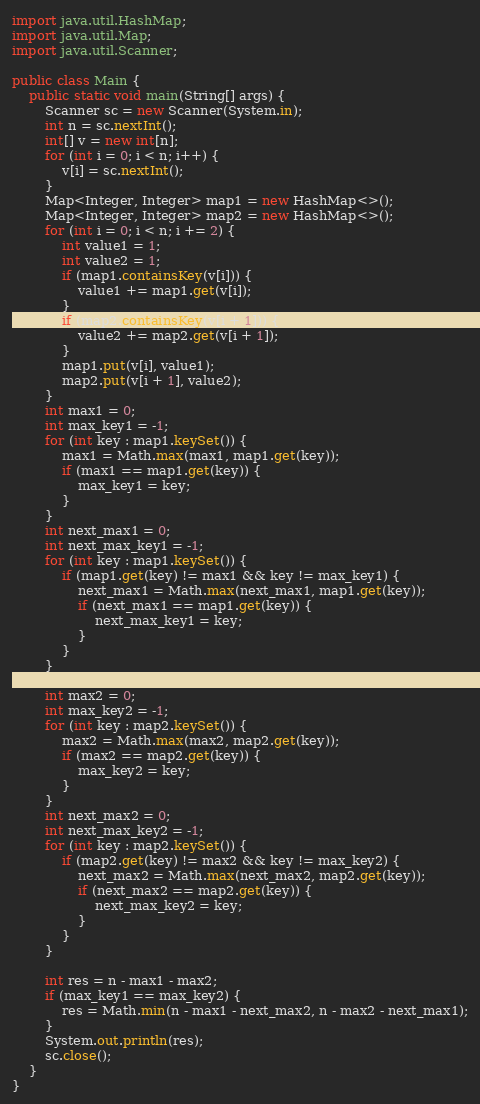<code> <loc_0><loc_0><loc_500><loc_500><_Java_>import java.util.HashMap;
import java.util.Map;
import java.util.Scanner;

public class Main {
    public static void main(String[] args) {
        Scanner sc = new Scanner(System.in);
        int n = sc.nextInt();
        int[] v = new int[n];
        for (int i = 0; i < n; i++) {
            v[i] = sc.nextInt();
        }
        Map<Integer, Integer> map1 = new HashMap<>();
        Map<Integer, Integer> map2 = new HashMap<>();
        for (int i = 0; i < n; i += 2) {
            int value1 = 1;
            int value2 = 1;
            if (map1.containsKey(v[i])) {
                value1 += map1.get(v[i]);
            }
            if (map2.containsKey(v[i + 1])) {
                value2 += map2.get(v[i + 1]);
            }
            map1.put(v[i], value1);
            map2.put(v[i + 1], value2);
        }
        int max1 = 0;
        int max_key1 = -1;
        for (int key : map1.keySet()) {
            max1 = Math.max(max1, map1.get(key));
            if (max1 == map1.get(key)) {
                max_key1 = key;
            }
        }
        int next_max1 = 0;
        int next_max_key1 = -1;
        for (int key : map1.keySet()) {
            if (map1.get(key) != max1 && key != max_key1) {
                next_max1 = Math.max(next_max1, map1.get(key));
                if (next_max1 == map1.get(key)) {
                    next_max_key1 = key;
                }
            }
        }

        int max2 = 0;
        int max_key2 = -1;
        for (int key : map2.keySet()) {
            max2 = Math.max(max2, map2.get(key));
            if (max2 == map2.get(key)) {
                max_key2 = key;
            }
        }
        int next_max2 = 0;
        int next_max_key2 = -1;
        for (int key : map2.keySet()) {
            if (map2.get(key) != max2 && key != max_key2) {
                next_max2 = Math.max(next_max2, map2.get(key));
                if (next_max2 == map2.get(key)) {
                    next_max_key2 = key;
                }
            }
        }

        int res = n - max1 - max2;
        if (max_key1 == max_key2) {
            res = Math.min(n - max1 - next_max2, n - max2 - next_max1);
        }
        System.out.println(res);
        sc.close();
    }
}</code> 